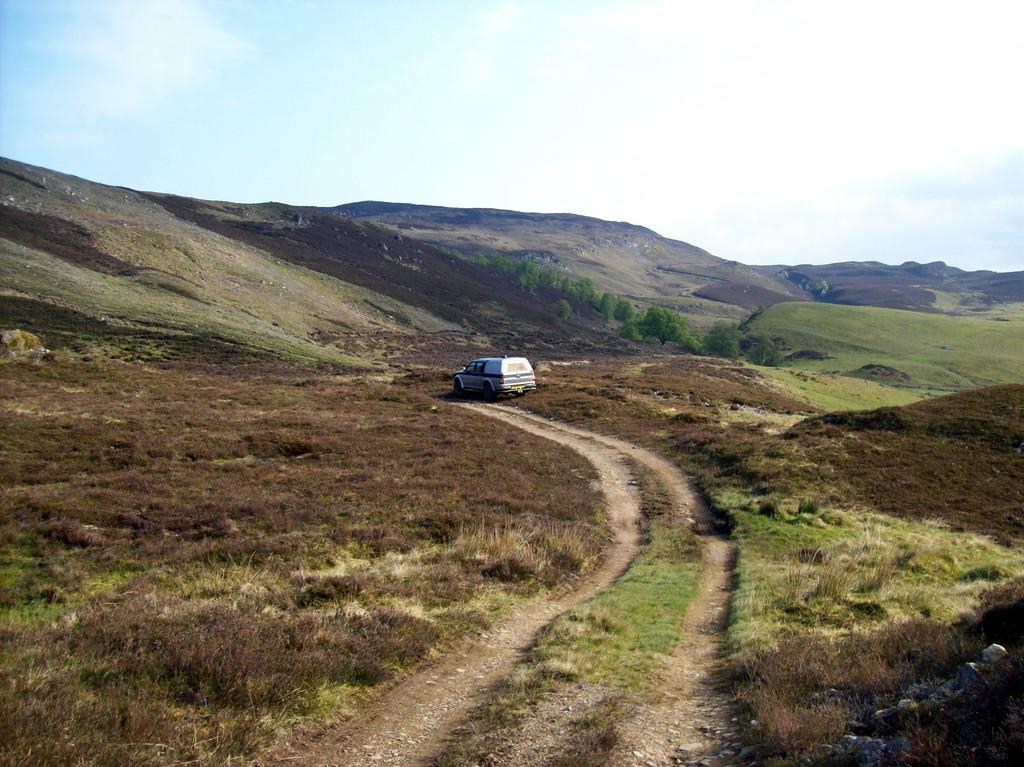What is the main subject of the image? There is a vehicle in the image. What type of terrain is visible in the image? There is grass, dried grass, stones, trees, and hills visible in the image. What is visible at the top of the image? The sky is visible at the top of the image. What type of book can be seen on the vehicle in the image? There is no book present on the vehicle in the image. What scent is associated with the dried grass in the image? The image does not provide any information about the scent of the dried grass. 